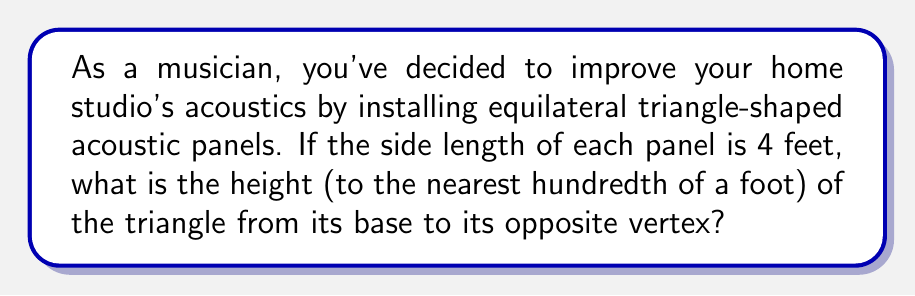Teach me how to tackle this problem. Let's approach this step-by-step:

1) In an equilateral triangle, all sides are equal and all angles are 60°.

2) The height of an equilateral triangle bisects the base, creating two right triangles.

3) Let's focus on one of these right triangles:
   - The hypotenuse is the side of the equilateral triangle (4 feet)
   - The base is half of the original triangle's side (2 feet)
   - The height of this right triangle is what we're looking for

4) We can use the Pythagorean theorem:

   $$a^2 + b^2 = c^2$$

   Where $a$ is the height we're solving for, $b$ is half the base (2 feet), and $c$ is the side length (4 feet).

5) Substituting our values:

   $$a^2 + 2^2 = 4^2$$

6) Simplify:

   $$a^2 + 4 = 16$$

7) Subtract 4 from both sides:

   $$a^2 = 12$$

8) Take the square root of both sides:

   $$a = \sqrt{12}$$

9) Simplify:

   $$a = 2\sqrt{3} \approx 3.4641$$

10) Rounding to the nearest hundredth:

    $$a \approx 3.46 \text{ feet}$$

[asy]
import geometry;

unitsize(30);
pair A = (0,0), B = (4,0), C = (2,2*sqrt(3));
draw(A--B--C--cycle);
draw(C--(2,0), dashed);
label("4'", (B+C)/2, E);
label("4'", (A+C)/2, W);
label("4'", (A+B)/2, S);
label("2'", (1,0), S);
label("2'", (3,0), S);
label("h", (2,sqrt(3)), E);
[/asy]
Answer: $3.46 \text{ feet}$ 